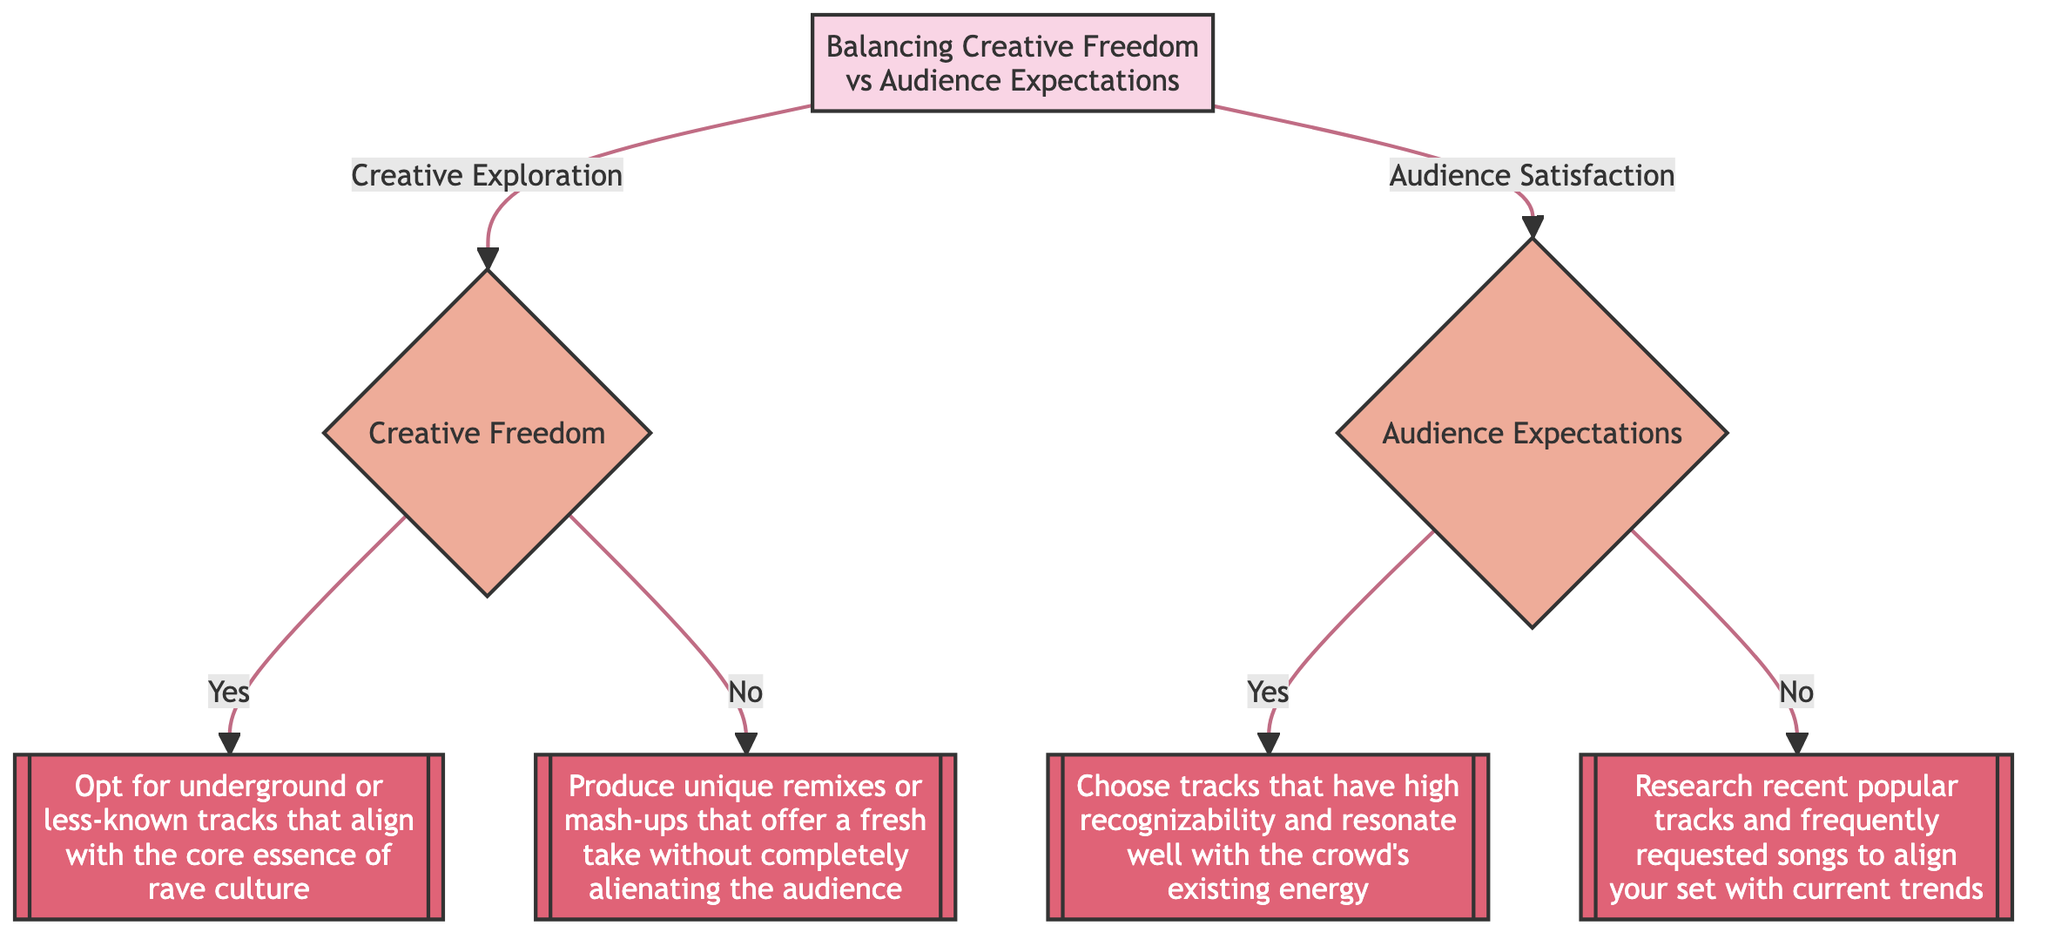What is the first question in the decision tree? The first question is located at the root node, which asks about the main objective at the event.
Answer: What is your main objective at this event? How many main branches are there in the decision tree? There are two main branches stemming from the root: Creative Freedom and Audience Expectations.
Answer: Two What should you do if you plan to introduce new tracks? If you plan to introduce new tracks, the next step in the decision tree directs you to Track Selection.
Answer: Track Selection What outcome is suggested if you choose not to introduce new tracks? If you choose not to introduce new tracks, the outcome leads to producing unique remixes or mash-ups.
Answer: Produce unique remixes or mash-ups that offer a fresh take without completely alienating the audience What does the tree suggest if you have a sense of the crowd's current mood? If you have a sense of the crowd's current mood, the next step suggests choosing tracks that resonate well with the crowd's existing energy.
Answer: Choose tracks that have high recognizability and resonate well with the crowd’s existing energy What action should you take if you don't have a sense of the crowd’s mood? If you don't have a sense of the crowd's mood, the decision tree suggests conducting Tunes Research to align your set with current trends.
Answer: Research recent popular tracks and frequently requested songs to align your set with current trends What is the relationship between Creative Exploration and Audience Satisfaction? Creative Exploration and Audience Satisfaction are the two primary choices stemming from the root node; they represent differing approaches to achieving the event's main objective.
Answer: Different approaches to achieving the event's main objective What decision leads to the choice of underground tracks? The decision to opt for underground tracks is made when the objective is Creative Exploration, and you plan to introduce new, unheard tracks.
Answer: Opt for underground or less-known tracks that align with the core essence of rave culture If new tracks are not introduced, what decision follows? If new tracks are not introduced, the decision leads to creating remixes or mash-ups as a way to balance creativity with audience expectations.
Answer: Remix & Mash-up 